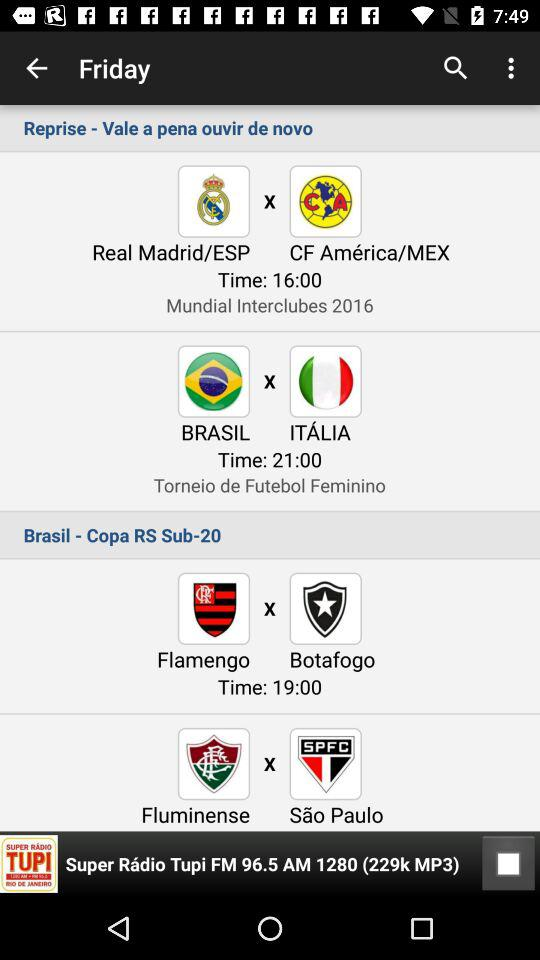Who is this application powered by?
When the provided information is insufficient, respond with <no answer>. <no answer> 